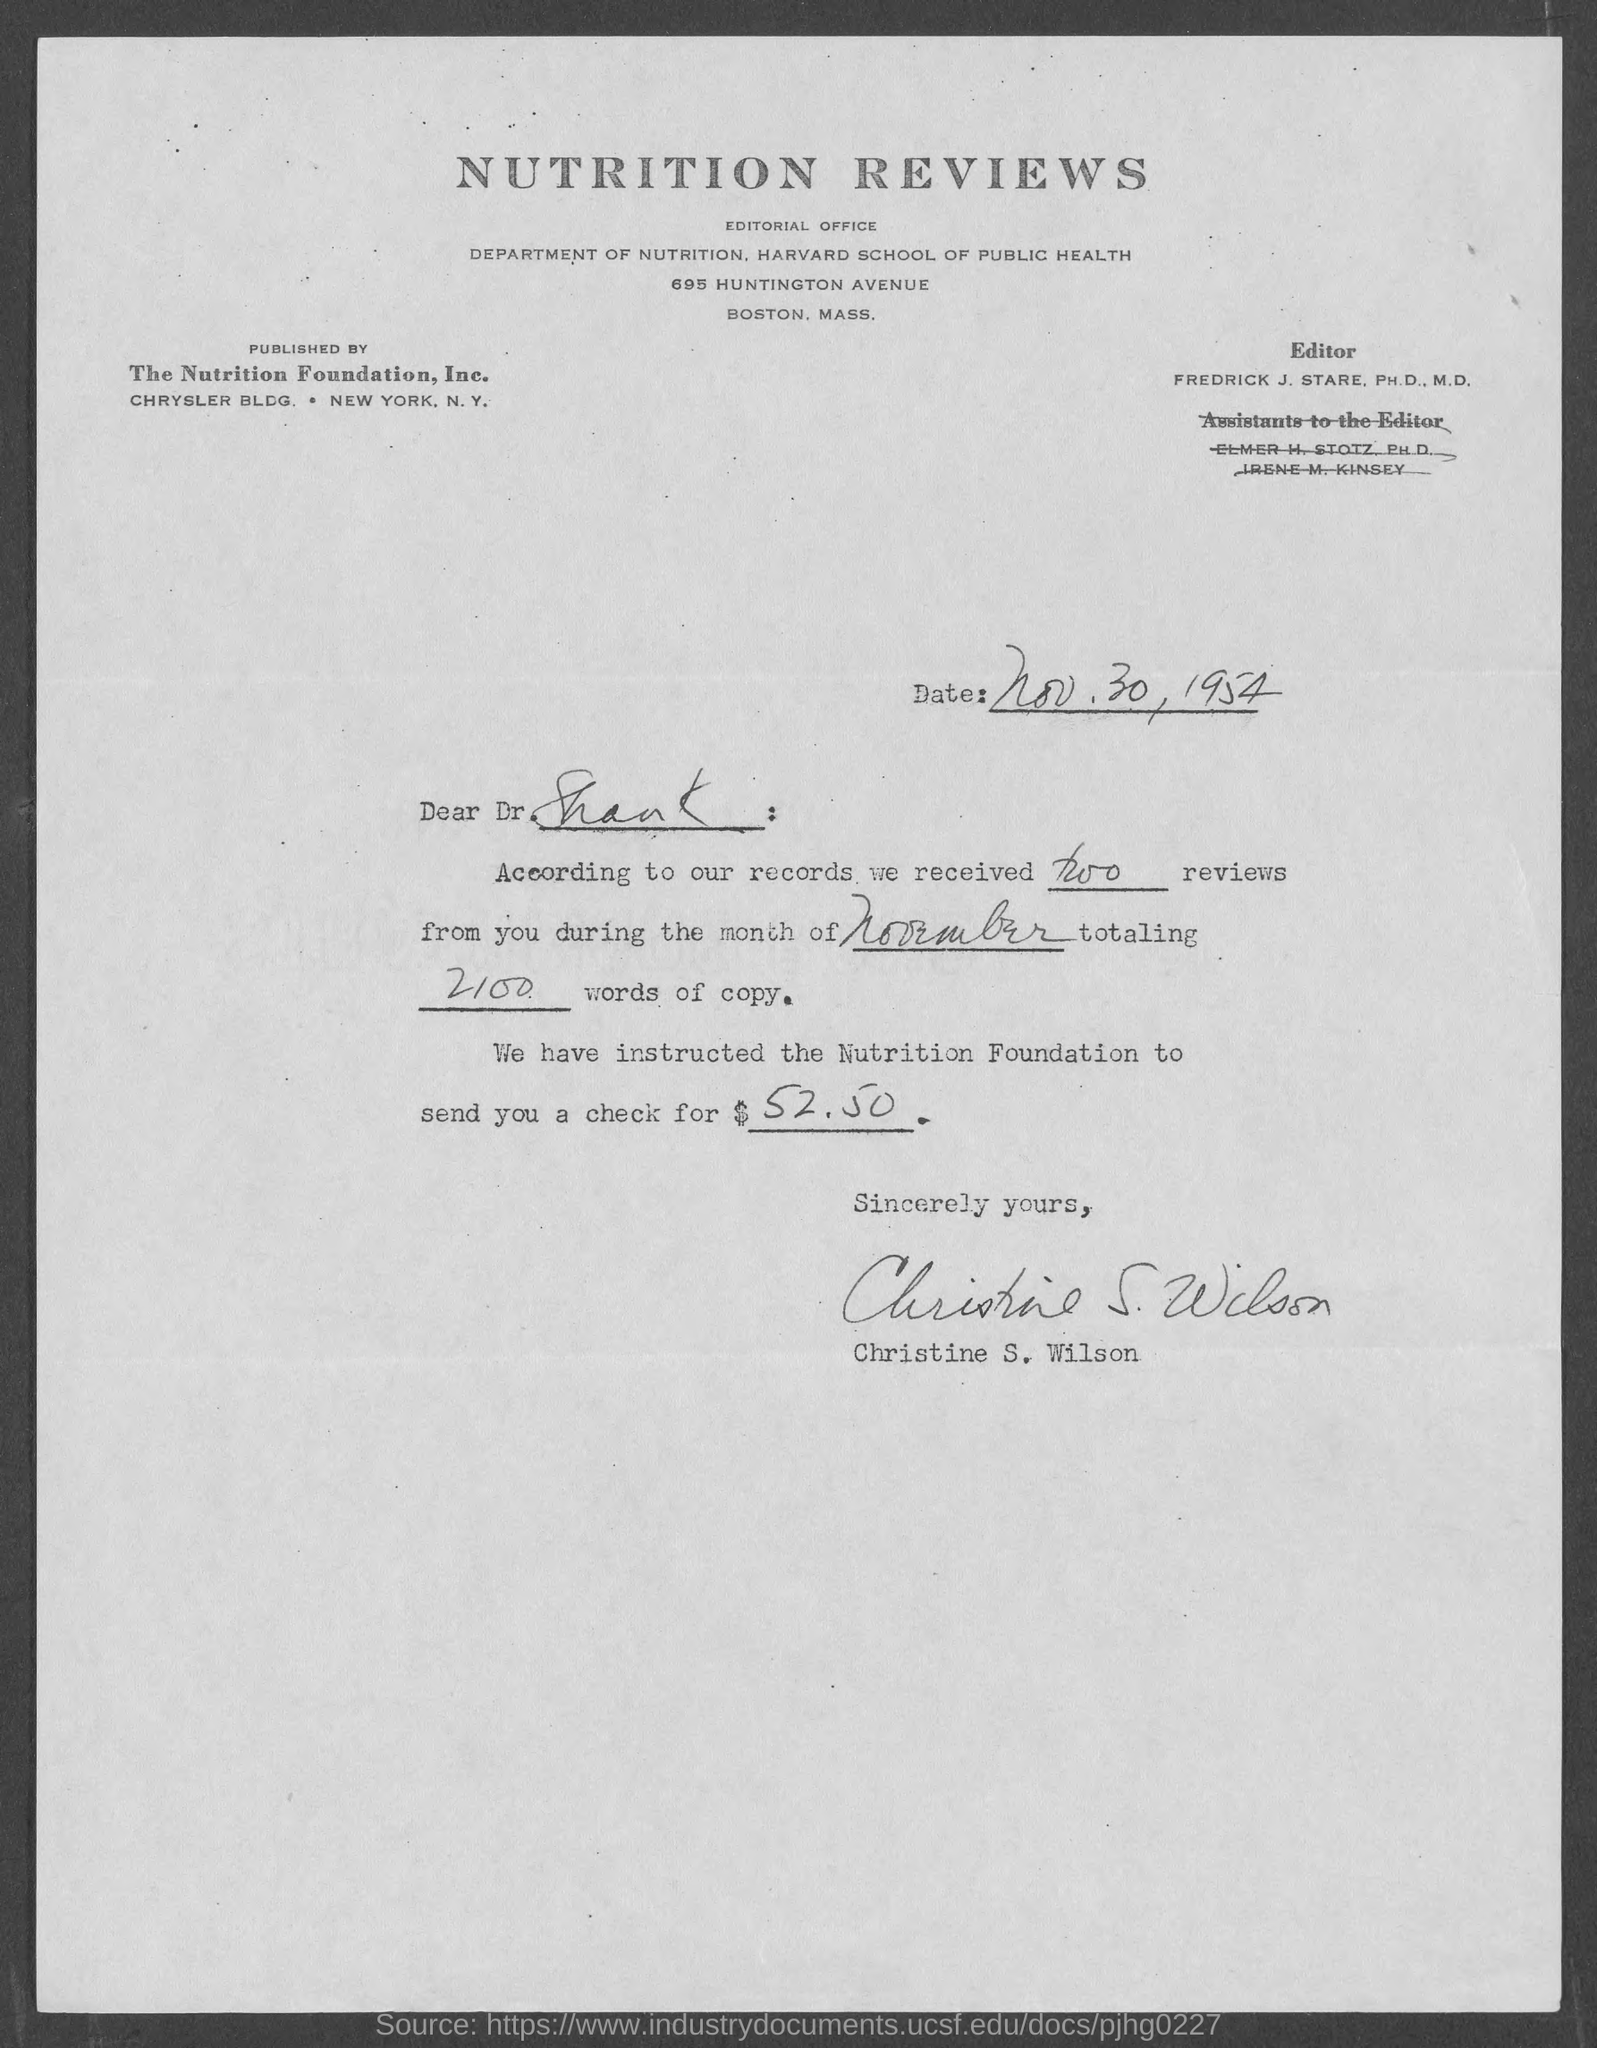What is the date mentioned in this letter?
Your response must be concise. Nov. 30, 1954. Who is the addressee of this letter?
Give a very brief answer. Dr. Shank. What is the check amount mentioned in the letter?
Provide a succinct answer. $52.50. Who has signed this letter?
Your answer should be very brief. Christine S. Wilson. 